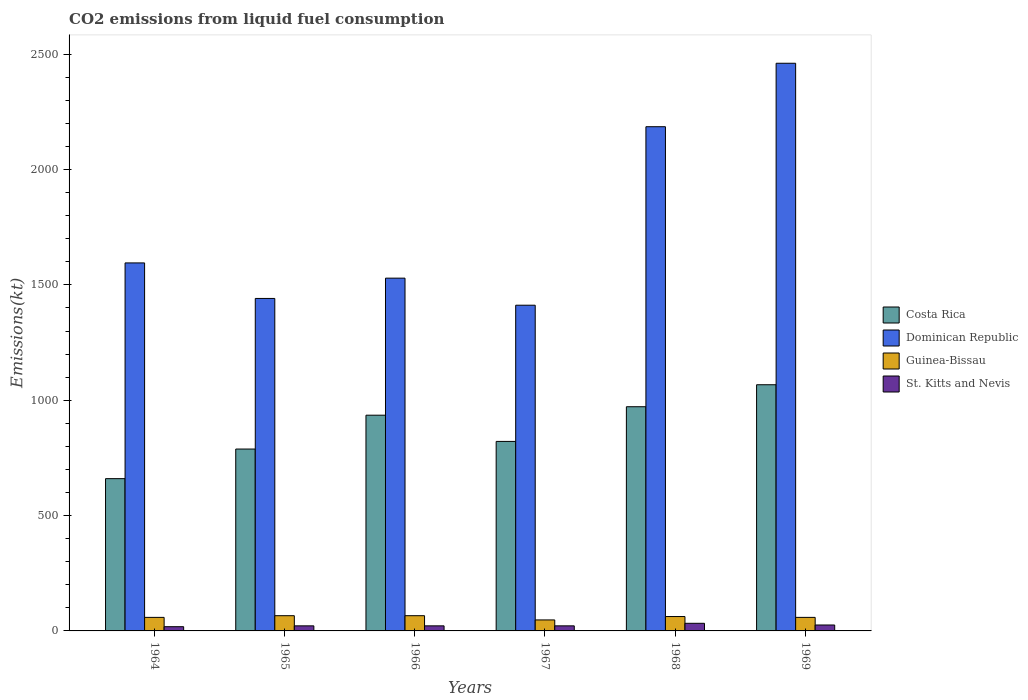How many groups of bars are there?
Provide a succinct answer. 6. Are the number of bars on each tick of the X-axis equal?
Keep it short and to the point. Yes. How many bars are there on the 4th tick from the right?
Offer a very short reply. 4. What is the label of the 6th group of bars from the left?
Your response must be concise. 1969. In how many cases, is the number of bars for a given year not equal to the number of legend labels?
Offer a terse response. 0. What is the amount of CO2 emitted in Guinea-Bissau in 1967?
Offer a terse response. 47.67. Across all years, what is the maximum amount of CO2 emitted in Guinea-Bissau?
Keep it short and to the point. 66.01. Across all years, what is the minimum amount of CO2 emitted in Costa Rica?
Ensure brevity in your answer.  660.06. In which year was the amount of CO2 emitted in St. Kitts and Nevis maximum?
Offer a very short reply. 1968. In which year was the amount of CO2 emitted in Costa Rica minimum?
Your answer should be compact. 1964. What is the total amount of CO2 emitted in Costa Rica in the graph?
Your response must be concise. 5243.81. What is the difference between the amount of CO2 emitted in Guinea-Bissau in 1965 and that in 1969?
Keep it short and to the point. 7.33. What is the difference between the amount of CO2 emitted in Costa Rica in 1968 and the amount of CO2 emitted in St. Kitts and Nevis in 1967?
Your response must be concise. 949.75. What is the average amount of CO2 emitted in Costa Rica per year?
Offer a terse response. 873.97. In the year 1964, what is the difference between the amount of CO2 emitted in Costa Rica and amount of CO2 emitted in Guinea-Bissau?
Your answer should be very brief. 601.39. In how many years, is the amount of CO2 emitted in Dominican Republic greater than 1900 kt?
Your answer should be compact. 2. What is the ratio of the amount of CO2 emitted in Guinea-Bissau in 1965 to that in 1967?
Offer a terse response. 1.38. Is the amount of CO2 emitted in Guinea-Bissau in 1967 less than that in 1969?
Give a very brief answer. Yes. What is the difference between the highest and the second highest amount of CO2 emitted in Costa Rica?
Keep it short and to the point. 95.34. What is the difference between the highest and the lowest amount of CO2 emitted in Costa Rica?
Ensure brevity in your answer.  407.04. In how many years, is the amount of CO2 emitted in St. Kitts and Nevis greater than the average amount of CO2 emitted in St. Kitts and Nevis taken over all years?
Give a very brief answer. 2. What does the 1st bar from the right in 1967 represents?
Provide a succinct answer. St. Kitts and Nevis. What is the title of the graph?
Keep it short and to the point. CO2 emissions from liquid fuel consumption. Does "Montenegro" appear as one of the legend labels in the graph?
Offer a very short reply. No. What is the label or title of the Y-axis?
Your response must be concise. Emissions(kt). What is the Emissions(kt) in Costa Rica in 1964?
Ensure brevity in your answer.  660.06. What is the Emissions(kt) in Dominican Republic in 1964?
Make the answer very short. 1595.14. What is the Emissions(kt) in Guinea-Bissau in 1964?
Give a very brief answer. 58.67. What is the Emissions(kt) in St. Kitts and Nevis in 1964?
Give a very brief answer. 18.34. What is the Emissions(kt) in Costa Rica in 1965?
Keep it short and to the point. 788.4. What is the Emissions(kt) in Dominican Republic in 1965?
Your response must be concise. 1441.13. What is the Emissions(kt) in Guinea-Bissau in 1965?
Offer a terse response. 66.01. What is the Emissions(kt) in St. Kitts and Nevis in 1965?
Make the answer very short. 22. What is the Emissions(kt) of Costa Rica in 1966?
Provide a succinct answer. 935.09. What is the Emissions(kt) of Dominican Republic in 1966?
Your answer should be compact. 1529.14. What is the Emissions(kt) in Guinea-Bissau in 1966?
Provide a succinct answer. 66.01. What is the Emissions(kt) of St. Kitts and Nevis in 1966?
Your response must be concise. 22. What is the Emissions(kt) in Costa Rica in 1967?
Offer a terse response. 821.41. What is the Emissions(kt) of Dominican Republic in 1967?
Give a very brief answer. 1411.8. What is the Emissions(kt) of Guinea-Bissau in 1967?
Offer a terse response. 47.67. What is the Emissions(kt) of St. Kitts and Nevis in 1967?
Keep it short and to the point. 22. What is the Emissions(kt) of Costa Rica in 1968?
Make the answer very short. 971.75. What is the Emissions(kt) of Dominican Republic in 1968?
Provide a succinct answer. 2185.53. What is the Emissions(kt) of Guinea-Bissau in 1968?
Keep it short and to the point. 62.34. What is the Emissions(kt) of St. Kitts and Nevis in 1968?
Give a very brief answer. 33. What is the Emissions(kt) of Costa Rica in 1969?
Your answer should be very brief. 1067.1. What is the Emissions(kt) in Dominican Republic in 1969?
Keep it short and to the point. 2460.56. What is the Emissions(kt) of Guinea-Bissau in 1969?
Your answer should be compact. 58.67. What is the Emissions(kt) in St. Kitts and Nevis in 1969?
Ensure brevity in your answer.  25.67. Across all years, what is the maximum Emissions(kt) of Costa Rica?
Give a very brief answer. 1067.1. Across all years, what is the maximum Emissions(kt) in Dominican Republic?
Ensure brevity in your answer.  2460.56. Across all years, what is the maximum Emissions(kt) in Guinea-Bissau?
Make the answer very short. 66.01. Across all years, what is the maximum Emissions(kt) in St. Kitts and Nevis?
Make the answer very short. 33. Across all years, what is the minimum Emissions(kt) in Costa Rica?
Provide a short and direct response. 660.06. Across all years, what is the minimum Emissions(kt) in Dominican Republic?
Offer a very short reply. 1411.8. Across all years, what is the minimum Emissions(kt) in Guinea-Bissau?
Your answer should be very brief. 47.67. Across all years, what is the minimum Emissions(kt) in St. Kitts and Nevis?
Your answer should be compact. 18.34. What is the total Emissions(kt) of Costa Rica in the graph?
Offer a terse response. 5243.81. What is the total Emissions(kt) in Dominican Republic in the graph?
Provide a short and direct response. 1.06e+04. What is the total Emissions(kt) in Guinea-Bissau in the graph?
Make the answer very short. 359.37. What is the total Emissions(kt) in St. Kitts and Nevis in the graph?
Give a very brief answer. 143.01. What is the difference between the Emissions(kt) of Costa Rica in 1964 and that in 1965?
Give a very brief answer. -128.34. What is the difference between the Emissions(kt) in Dominican Republic in 1964 and that in 1965?
Provide a short and direct response. 154.01. What is the difference between the Emissions(kt) of Guinea-Bissau in 1964 and that in 1965?
Your answer should be compact. -7.33. What is the difference between the Emissions(kt) in St. Kitts and Nevis in 1964 and that in 1965?
Provide a succinct answer. -3.67. What is the difference between the Emissions(kt) in Costa Rica in 1964 and that in 1966?
Keep it short and to the point. -275.02. What is the difference between the Emissions(kt) in Dominican Republic in 1964 and that in 1966?
Keep it short and to the point. 66.01. What is the difference between the Emissions(kt) of Guinea-Bissau in 1964 and that in 1966?
Ensure brevity in your answer.  -7.33. What is the difference between the Emissions(kt) in St. Kitts and Nevis in 1964 and that in 1966?
Offer a very short reply. -3.67. What is the difference between the Emissions(kt) of Costa Rica in 1964 and that in 1967?
Offer a very short reply. -161.35. What is the difference between the Emissions(kt) of Dominican Republic in 1964 and that in 1967?
Your response must be concise. 183.35. What is the difference between the Emissions(kt) of Guinea-Bissau in 1964 and that in 1967?
Your answer should be compact. 11. What is the difference between the Emissions(kt) in St. Kitts and Nevis in 1964 and that in 1967?
Give a very brief answer. -3.67. What is the difference between the Emissions(kt) of Costa Rica in 1964 and that in 1968?
Give a very brief answer. -311.69. What is the difference between the Emissions(kt) in Dominican Republic in 1964 and that in 1968?
Offer a very short reply. -590.39. What is the difference between the Emissions(kt) in Guinea-Bissau in 1964 and that in 1968?
Provide a short and direct response. -3.67. What is the difference between the Emissions(kt) of St. Kitts and Nevis in 1964 and that in 1968?
Give a very brief answer. -14.67. What is the difference between the Emissions(kt) in Costa Rica in 1964 and that in 1969?
Provide a succinct answer. -407.04. What is the difference between the Emissions(kt) of Dominican Republic in 1964 and that in 1969?
Provide a succinct answer. -865.41. What is the difference between the Emissions(kt) of Guinea-Bissau in 1964 and that in 1969?
Provide a short and direct response. 0. What is the difference between the Emissions(kt) of St. Kitts and Nevis in 1964 and that in 1969?
Provide a short and direct response. -7.33. What is the difference between the Emissions(kt) in Costa Rica in 1965 and that in 1966?
Your answer should be compact. -146.68. What is the difference between the Emissions(kt) in Dominican Republic in 1965 and that in 1966?
Your answer should be very brief. -88.01. What is the difference between the Emissions(kt) of Guinea-Bissau in 1965 and that in 1966?
Give a very brief answer. 0. What is the difference between the Emissions(kt) in Costa Rica in 1965 and that in 1967?
Provide a short and direct response. -33. What is the difference between the Emissions(kt) of Dominican Republic in 1965 and that in 1967?
Your response must be concise. 29.34. What is the difference between the Emissions(kt) of Guinea-Bissau in 1965 and that in 1967?
Ensure brevity in your answer.  18.34. What is the difference between the Emissions(kt) of Costa Rica in 1965 and that in 1968?
Keep it short and to the point. -183.35. What is the difference between the Emissions(kt) in Dominican Republic in 1965 and that in 1968?
Keep it short and to the point. -744.4. What is the difference between the Emissions(kt) of Guinea-Bissau in 1965 and that in 1968?
Keep it short and to the point. 3.67. What is the difference between the Emissions(kt) in St. Kitts and Nevis in 1965 and that in 1968?
Offer a very short reply. -11. What is the difference between the Emissions(kt) of Costa Rica in 1965 and that in 1969?
Offer a very short reply. -278.69. What is the difference between the Emissions(kt) in Dominican Republic in 1965 and that in 1969?
Provide a short and direct response. -1019.43. What is the difference between the Emissions(kt) of Guinea-Bissau in 1965 and that in 1969?
Ensure brevity in your answer.  7.33. What is the difference between the Emissions(kt) of St. Kitts and Nevis in 1965 and that in 1969?
Ensure brevity in your answer.  -3.67. What is the difference between the Emissions(kt) of Costa Rica in 1966 and that in 1967?
Your answer should be very brief. 113.68. What is the difference between the Emissions(kt) of Dominican Republic in 1966 and that in 1967?
Offer a very short reply. 117.34. What is the difference between the Emissions(kt) in Guinea-Bissau in 1966 and that in 1967?
Your answer should be compact. 18.34. What is the difference between the Emissions(kt) of Costa Rica in 1966 and that in 1968?
Your response must be concise. -36.67. What is the difference between the Emissions(kt) in Dominican Republic in 1966 and that in 1968?
Make the answer very short. -656.39. What is the difference between the Emissions(kt) in Guinea-Bissau in 1966 and that in 1968?
Give a very brief answer. 3.67. What is the difference between the Emissions(kt) of St. Kitts and Nevis in 1966 and that in 1968?
Your answer should be compact. -11. What is the difference between the Emissions(kt) in Costa Rica in 1966 and that in 1969?
Give a very brief answer. -132.01. What is the difference between the Emissions(kt) in Dominican Republic in 1966 and that in 1969?
Your response must be concise. -931.42. What is the difference between the Emissions(kt) in Guinea-Bissau in 1966 and that in 1969?
Keep it short and to the point. 7.33. What is the difference between the Emissions(kt) of St. Kitts and Nevis in 1966 and that in 1969?
Your response must be concise. -3.67. What is the difference between the Emissions(kt) in Costa Rica in 1967 and that in 1968?
Make the answer very short. -150.35. What is the difference between the Emissions(kt) of Dominican Republic in 1967 and that in 1968?
Give a very brief answer. -773.74. What is the difference between the Emissions(kt) in Guinea-Bissau in 1967 and that in 1968?
Your answer should be very brief. -14.67. What is the difference between the Emissions(kt) in St. Kitts and Nevis in 1967 and that in 1968?
Give a very brief answer. -11. What is the difference between the Emissions(kt) in Costa Rica in 1967 and that in 1969?
Offer a very short reply. -245.69. What is the difference between the Emissions(kt) in Dominican Republic in 1967 and that in 1969?
Your response must be concise. -1048.76. What is the difference between the Emissions(kt) in Guinea-Bissau in 1967 and that in 1969?
Your response must be concise. -11. What is the difference between the Emissions(kt) in St. Kitts and Nevis in 1967 and that in 1969?
Your answer should be very brief. -3.67. What is the difference between the Emissions(kt) in Costa Rica in 1968 and that in 1969?
Offer a terse response. -95.34. What is the difference between the Emissions(kt) of Dominican Republic in 1968 and that in 1969?
Keep it short and to the point. -275.02. What is the difference between the Emissions(kt) of Guinea-Bissau in 1968 and that in 1969?
Give a very brief answer. 3.67. What is the difference between the Emissions(kt) of St. Kitts and Nevis in 1968 and that in 1969?
Your answer should be compact. 7.33. What is the difference between the Emissions(kt) of Costa Rica in 1964 and the Emissions(kt) of Dominican Republic in 1965?
Offer a very short reply. -781.07. What is the difference between the Emissions(kt) in Costa Rica in 1964 and the Emissions(kt) in Guinea-Bissau in 1965?
Provide a succinct answer. 594.05. What is the difference between the Emissions(kt) in Costa Rica in 1964 and the Emissions(kt) in St. Kitts and Nevis in 1965?
Offer a terse response. 638.06. What is the difference between the Emissions(kt) of Dominican Republic in 1964 and the Emissions(kt) of Guinea-Bissau in 1965?
Ensure brevity in your answer.  1529.14. What is the difference between the Emissions(kt) in Dominican Republic in 1964 and the Emissions(kt) in St. Kitts and Nevis in 1965?
Your answer should be compact. 1573.14. What is the difference between the Emissions(kt) in Guinea-Bissau in 1964 and the Emissions(kt) in St. Kitts and Nevis in 1965?
Offer a terse response. 36.67. What is the difference between the Emissions(kt) of Costa Rica in 1964 and the Emissions(kt) of Dominican Republic in 1966?
Make the answer very short. -869.08. What is the difference between the Emissions(kt) of Costa Rica in 1964 and the Emissions(kt) of Guinea-Bissau in 1966?
Provide a succinct answer. 594.05. What is the difference between the Emissions(kt) in Costa Rica in 1964 and the Emissions(kt) in St. Kitts and Nevis in 1966?
Your response must be concise. 638.06. What is the difference between the Emissions(kt) in Dominican Republic in 1964 and the Emissions(kt) in Guinea-Bissau in 1966?
Give a very brief answer. 1529.14. What is the difference between the Emissions(kt) of Dominican Republic in 1964 and the Emissions(kt) of St. Kitts and Nevis in 1966?
Make the answer very short. 1573.14. What is the difference between the Emissions(kt) of Guinea-Bissau in 1964 and the Emissions(kt) of St. Kitts and Nevis in 1966?
Provide a short and direct response. 36.67. What is the difference between the Emissions(kt) in Costa Rica in 1964 and the Emissions(kt) in Dominican Republic in 1967?
Your answer should be compact. -751.74. What is the difference between the Emissions(kt) in Costa Rica in 1964 and the Emissions(kt) in Guinea-Bissau in 1967?
Provide a short and direct response. 612.39. What is the difference between the Emissions(kt) in Costa Rica in 1964 and the Emissions(kt) in St. Kitts and Nevis in 1967?
Your response must be concise. 638.06. What is the difference between the Emissions(kt) of Dominican Republic in 1964 and the Emissions(kt) of Guinea-Bissau in 1967?
Provide a short and direct response. 1547.47. What is the difference between the Emissions(kt) in Dominican Republic in 1964 and the Emissions(kt) in St. Kitts and Nevis in 1967?
Provide a short and direct response. 1573.14. What is the difference between the Emissions(kt) in Guinea-Bissau in 1964 and the Emissions(kt) in St. Kitts and Nevis in 1967?
Offer a terse response. 36.67. What is the difference between the Emissions(kt) of Costa Rica in 1964 and the Emissions(kt) of Dominican Republic in 1968?
Your response must be concise. -1525.47. What is the difference between the Emissions(kt) of Costa Rica in 1964 and the Emissions(kt) of Guinea-Bissau in 1968?
Your answer should be very brief. 597.72. What is the difference between the Emissions(kt) in Costa Rica in 1964 and the Emissions(kt) in St. Kitts and Nevis in 1968?
Offer a very short reply. 627.06. What is the difference between the Emissions(kt) of Dominican Republic in 1964 and the Emissions(kt) of Guinea-Bissau in 1968?
Offer a terse response. 1532.81. What is the difference between the Emissions(kt) of Dominican Republic in 1964 and the Emissions(kt) of St. Kitts and Nevis in 1968?
Your response must be concise. 1562.14. What is the difference between the Emissions(kt) in Guinea-Bissau in 1964 and the Emissions(kt) in St. Kitts and Nevis in 1968?
Your answer should be compact. 25.67. What is the difference between the Emissions(kt) of Costa Rica in 1964 and the Emissions(kt) of Dominican Republic in 1969?
Offer a terse response. -1800.5. What is the difference between the Emissions(kt) of Costa Rica in 1964 and the Emissions(kt) of Guinea-Bissau in 1969?
Provide a succinct answer. 601.39. What is the difference between the Emissions(kt) of Costa Rica in 1964 and the Emissions(kt) of St. Kitts and Nevis in 1969?
Keep it short and to the point. 634.39. What is the difference between the Emissions(kt) of Dominican Republic in 1964 and the Emissions(kt) of Guinea-Bissau in 1969?
Offer a very short reply. 1536.47. What is the difference between the Emissions(kt) in Dominican Republic in 1964 and the Emissions(kt) in St. Kitts and Nevis in 1969?
Offer a terse response. 1569.48. What is the difference between the Emissions(kt) in Guinea-Bissau in 1964 and the Emissions(kt) in St. Kitts and Nevis in 1969?
Offer a terse response. 33. What is the difference between the Emissions(kt) in Costa Rica in 1965 and the Emissions(kt) in Dominican Republic in 1966?
Keep it short and to the point. -740.73. What is the difference between the Emissions(kt) of Costa Rica in 1965 and the Emissions(kt) of Guinea-Bissau in 1966?
Provide a short and direct response. 722.4. What is the difference between the Emissions(kt) in Costa Rica in 1965 and the Emissions(kt) in St. Kitts and Nevis in 1966?
Your answer should be very brief. 766.4. What is the difference between the Emissions(kt) in Dominican Republic in 1965 and the Emissions(kt) in Guinea-Bissau in 1966?
Offer a terse response. 1375.12. What is the difference between the Emissions(kt) in Dominican Republic in 1965 and the Emissions(kt) in St. Kitts and Nevis in 1966?
Your answer should be compact. 1419.13. What is the difference between the Emissions(kt) in Guinea-Bissau in 1965 and the Emissions(kt) in St. Kitts and Nevis in 1966?
Offer a very short reply. 44. What is the difference between the Emissions(kt) of Costa Rica in 1965 and the Emissions(kt) of Dominican Republic in 1967?
Give a very brief answer. -623.39. What is the difference between the Emissions(kt) of Costa Rica in 1965 and the Emissions(kt) of Guinea-Bissau in 1967?
Ensure brevity in your answer.  740.73. What is the difference between the Emissions(kt) of Costa Rica in 1965 and the Emissions(kt) of St. Kitts and Nevis in 1967?
Make the answer very short. 766.4. What is the difference between the Emissions(kt) in Dominican Republic in 1965 and the Emissions(kt) in Guinea-Bissau in 1967?
Give a very brief answer. 1393.46. What is the difference between the Emissions(kt) of Dominican Republic in 1965 and the Emissions(kt) of St. Kitts and Nevis in 1967?
Make the answer very short. 1419.13. What is the difference between the Emissions(kt) of Guinea-Bissau in 1965 and the Emissions(kt) of St. Kitts and Nevis in 1967?
Provide a succinct answer. 44. What is the difference between the Emissions(kt) in Costa Rica in 1965 and the Emissions(kt) in Dominican Republic in 1968?
Make the answer very short. -1397.13. What is the difference between the Emissions(kt) in Costa Rica in 1965 and the Emissions(kt) in Guinea-Bissau in 1968?
Keep it short and to the point. 726.07. What is the difference between the Emissions(kt) of Costa Rica in 1965 and the Emissions(kt) of St. Kitts and Nevis in 1968?
Keep it short and to the point. 755.4. What is the difference between the Emissions(kt) of Dominican Republic in 1965 and the Emissions(kt) of Guinea-Bissau in 1968?
Provide a short and direct response. 1378.79. What is the difference between the Emissions(kt) in Dominican Republic in 1965 and the Emissions(kt) in St. Kitts and Nevis in 1968?
Provide a succinct answer. 1408.13. What is the difference between the Emissions(kt) of Guinea-Bissau in 1965 and the Emissions(kt) of St. Kitts and Nevis in 1968?
Provide a short and direct response. 33. What is the difference between the Emissions(kt) in Costa Rica in 1965 and the Emissions(kt) in Dominican Republic in 1969?
Offer a terse response. -1672.15. What is the difference between the Emissions(kt) of Costa Rica in 1965 and the Emissions(kt) of Guinea-Bissau in 1969?
Give a very brief answer. 729.73. What is the difference between the Emissions(kt) of Costa Rica in 1965 and the Emissions(kt) of St. Kitts and Nevis in 1969?
Offer a very short reply. 762.74. What is the difference between the Emissions(kt) in Dominican Republic in 1965 and the Emissions(kt) in Guinea-Bissau in 1969?
Your answer should be very brief. 1382.46. What is the difference between the Emissions(kt) in Dominican Republic in 1965 and the Emissions(kt) in St. Kitts and Nevis in 1969?
Keep it short and to the point. 1415.46. What is the difference between the Emissions(kt) in Guinea-Bissau in 1965 and the Emissions(kt) in St. Kitts and Nevis in 1969?
Ensure brevity in your answer.  40.34. What is the difference between the Emissions(kt) in Costa Rica in 1966 and the Emissions(kt) in Dominican Republic in 1967?
Your response must be concise. -476.71. What is the difference between the Emissions(kt) of Costa Rica in 1966 and the Emissions(kt) of Guinea-Bissau in 1967?
Keep it short and to the point. 887.41. What is the difference between the Emissions(kt) of Costa Rica in 1966 and the Emissions(kt) of St. Kitts and Nevis in 1967?
Ensure brevity in your answer.  913.08. What is the difference between the Emissions(kt) of Dominican Republic in 1966 and the Emissions(kt) of Guinea-Bissau in 1967?
Your answer should be compact. 1481.47. What is the difference between the Emissions(kt) in Dominican Republic in 1966 and the Emissions(kt) in St. Kitts and Nevis in 1967?
Make the answer very short. 1507.14. What is the difference between the Emissions(kt) of Guinea-Bissau in 1966 and the Emissions(kt) of St. Kitts and Nevis in 1967?
Provide a short and direct response. 44. What is the difference between the Emissions(kt) of Costa Rica in 1966 and the Emissions(kt) of Dominican Republic in 1968?
Offer a terse response. -1250.45. What is the difference between the Emissions(kt) of Costa Rica in 1966 and the Emissions(kt) of Guinea-Bissau in 1968?
Your answer should be very brief. 872.75. What is the difference between the Emissions(kt) in Costa Rica in 1966 and the Emissions(kt) in St. Kitts and Nevis in 1968?
Provide a succinct answer. 902.08. What is the difference between the Emissions(kt) in Dominican Republic in 1966 and the Emissions(kt) in Guinea-Bissau in 1968?
Your answer should be compact. 1466.8. What is the difference between the Emissions(kt) of Dominican Republic in 1966 and the Emissions(kt) of St. Kitts and Nevis in 1968?
Your answer should be compact. 1496.14. What is the difference between the Emissions(kt) of Guinea-Bissau in 1966 and the Emissions(kt) of St. Kitts and Nevis in 1968?
Offer a terse response. 33. What is the difference between the Emissions(kt) in Costa Rica in 1966 and the Emissions(kt) in Dominican Republic in 1969?
Your answer should be compact. -1525.47. What is the difference between the Emissions(kt) of Costa Rica in 1966 and the Emissions(kt) of Guinea-Bissau in 1969?
Provide a succinct answer. 876.41. What is the difference between the Emissions(kt) in Costa Rica in 1966 and the Emissions(kt) in St. Kitts and Nevis in 1969?
Provide a short and direct response. 909.42. What is the difference between the Emissions(kt) of Dominican Republic in 1966 and the Emissions(kt) of Guinea-Bissau in 1969?
Provide a succinct answer. 1470.47. What is the difference between the Emissions(kt) in Dominican Republic in 1966 and the Emissions(kt) in St. Kitts and Nevis in 1969?
Ensure brevity in your answer.  1503.47. What is the difference between the Emissions(kt) of Guinea-Bissau in 1966 and the Emissions(kt) of St. Kitts and Nevis in 1969?
Offer a very short reply. 40.34. What is the difference between the Emissions(kt) of Costa Rica in 1967 and the Emissions(kt) of Dominican Republic in 1968?
Your answer should be very brief. -1364.12. What is the difference between the Emissions(kt) of Costa Rica in 1967 and the Emissions(kt) of Guinea-Bissau in 1968?
Keep it short and to the point. 759.07. What is the difference between the Emissions(kt) in Costa Rica in 1967 and the Emissions(kt) in St. Kitts and Nevis in 1968?
Your answer should be compact. 788.4. What is the difference between the Emissions(kt) of Dominican Republic in 1967 and the Emissions(kt) of Guinea-Bissau in 1968?
Give a very brief answer. 1349.46. What is the difference between the Emissions(kt) of Dominican Republic in 1967 and the Emissions(kt) of St. Kitts and Nevis in 1968?
Make the answer very short. 1378.79. What is the difference between the Emissions(kt) in Guinea-Bissau in 1967 and the Emissions(kt) in St. Kitts and Nevis in 1968?
Your response must be concise. 14.67. What is the difference between the Emissions(kt) in Costa Rica in 1967 and the Emissions(kt) in Dominican Republic in 1969?
Your answer should be compact. -1639.15. What is the difference between the Emissions(kt) of Costa Rica in 1967 and the Emissions(kt) of Guinea-Bissau in 1969?
Offer a terse response. 762.74. What is the difference between the Emissions(kt) in Costa Rica in 1967 and the Emissions(kt) in St. Kitts and Nevis in 1969?
Offer a very short reply. 795.74. What is the difference between the Emissions(kt) of Dominican Republic in 1967 and the Emissions(kt) of Guinea-Bissau in 1969?
Your response must be concise. 1353.12. What is the difference between the Emissions(kt) in Dominican Republic in 1967 and the Emissions(kt) in St. Kitts and Nevis in 1969?
Keep it short and to the point. 1386.13. What is the difference between the Emissions(kt) of Guinea-Bissau in 1967 and the Emissions(kt) of St. Kitts and Nevis in 1969?
Provide a short and direct response. 22. What is the difference between the Emissions(kt) of Costa Rica in 1968 and the Emissions(kt) of Dominican Republic in 1969?
Provide a short and direct response. -1488.8. What is the difference between the Emissions(kt) in Costa Rica in 1968 and the Emissions(kt) in Guinea-Bissau in 1969?
Offer a very short reply. 913.08. What is the difference between the Emissions(kt) of Costa Rica in 1968 and the Emissions(kt) of St. Kitts and Nevis in 1969?
Offer a very short reply. 946.09. What is the difference between the Emissions(kt) in Dominican Republic in 1968 and the Emissions(kt) in Guinea-Bissau in 1969?
Your response must be concise. 2126.86. What is the difference between the Emissions(kt) in Dominican Republic in 1968 and the Emissions(kt) in St. Kitts and Nevis in 1969?
Provide a succinct answer. 2159.86. What is the difference between the Emissions(kt) of Guinea-Bissau in 1968 and the Emissions(kt) of St. Kitts and Nevis in 1969?
Provide a succinct answer. 36.67. What is the average Emissions(kt) in Costa Rica per year?
Your answer should be very brief. 873.97. What is the average Emissions(kt) of Dominican Republic per year?
Your response must be concise. 1770.55. What is the average Emissions(kt) in Guinea-Bissau per year?
Offer a very short reply. 59.89. What is the average Emissions(kt) in St. Kitts and Nevis per year?
Ensure brevity in your answer.  23.84. In the year 1964, what is the difference between the Emissions(kt) of Costa Rica and Emissions(kt) of Dominican Republic?
Your response must be concise. -935.09. In the year 1964, what is the difference between the Emissions(kt) in Costa Rica and Emissions(kt) in Guinea-Bissau?
Offer a terse response. 601.39. In the year 1964, what is the difference between the Emissions(kt) in Costa Rica and Emissions(kt) in St. Kitts and Nevis?
Offer a very short reply. 641.73. In the year 1964, what is the difference between the Emissions(kt) of Dominican Republic and Emissions(kt) of Guinea-Bissau?
Give a very brief answer. 1536.47. In the year 1964, what is the difference between the Emissions(kt) in Dominican Republic and Emissions(kt) in St. Kitts and Nevis?
Ensure brevity in your answer.  1576.81. In the year 1964, what is the difference between the Emissions(kt) of Guinea-Bissau and Emissions(kt) of St. Kitts and Nevis?
Offer a very short reply. 40.34. In the year 1965, what is the difference between the Emissions(kt) of Costa Rica and Emissions(kt) of Dominican Republic?
Ensure brevity in your answer.  -652.73. In the year 1965, what is the difference between the Emissions(kt) of Costa Rica and Emissions(kt) of Guinea-Bissau?
Ensure brevity in your answer.  722.4. In the year 1965, what is the difference between the Emissions(kt) of Costa Rica and Emissions(kt) of St. Kitts and Nevis?
Your answer should be compact. 766.4. In the year 1965, what is the difference between the Emissions(kt) in Dominican Republic and Emissions(kt) in Guinea-Bissau?
Ensure brevity in your answer.  1375.12. In the year 1965, what is the difference between the Emissions(kt) of Dominican Republic and Emissions(kt) of St. Kitts and Nevis?
Give a very brief answer. 1419.13. In the year 1965, what is the difference between the Emissions(kt) in Guinea-Bissau and Emissions(kt) in St. Kitts and Nevis?
Offer a terse response. 44. In the year 1966, what is the difference between the Emissions(kt) in Costa Rica and Emissions(kt) in Dominican Republic?
Ensure brevity in your answer.  -594.05. In the year 1966, what is the difference between the Emissions(kt) in Costa Rica and Emissions(kt) in Guinea-Bissau?
Make the answer very short. 869.08. In the year 1966, what is the difference between the Emissions(kt) in Costa Rica and Emissions(kt) in St. Kitts and Nevis?
Provide a succinct answer. 913.08. In the year 1966, what is the difference between the Emissions(kt) in Dominican Republic and Emissions(kt) in Guinea-Bissau?
Give a very brief answer. 1463.13. In the year 1966, what is the difference between the Emissions(kt) in Dominican Republic and Emissions(kt) in St. Kitts and Nevis?
Give a very brief answer. 1507.14. In the year 1966, what is the difference between the Emissions(kt) of Guinea-Bissau and Emissions(kt) of St. Kitts and Nevis?
Provide a succinct answer. 44. In the year 1967, what is the difference between the Emissions(kt) in Costa Rica and Emissions(kt) in Dominican Republic?
Provide a short and direct response. -590.39. In the year 1967, what is the difference between the Emissions(kt) in Costa Rica and Emissions(kt) in Guinea-Bissau?
Your response must be concise. 773.74. In the year 1967, what is the difference between the Emissions(kt) of Costa Rica and Emissions(kt) of St. Kitts and Nevis?
Offer a very short reply. 799.41. In the year 1967, what is the difference between the Emissions(kt) in Dominican Republic and Emissions(kt) in Guinea-Bissau?
Provide a succinct answer. 1364.12. In the year 1967, what is the difference between the Emissions(kt) of Dominican Republic and Emissions(kt) of St. Kitts and Nevis?
Your answer should be compact. 1389.79. In the year 1967, what is the difference between the Emissions(kt) of Guinea-Bissau and Emissions(kt) of St. Kitts and Nevis?
Offer a terse response. 25.67. In the year 1968, what is the difference between the Emissions(kt) of Costa Rica and Emissions(kt) of Dominican Republic?
Offer a very short reply. -1213.78. In the year 1968, what is the difference between the Emissions(kt) in Costa Rica and Emissions(kt) in Guinea-Bissau?
Make the answer very short. 909.42. In the year 1968, what is the difference between the Emissions(kt) in Costa Rica and Emissions(kt) in St. Kitts and Nevis?
Give a very brief answer. 938.75. In the year 1968, what is the difference between the Emissions(kt) of Dominican Republic and Emissions(kt) of Guinea-Bissau?
Offer a terse response. 2123.19. In the year 1968, what is the difference between the Emissions(kt) in Dominican Republic and Emissions(kt) in St. Kitts and Nevis?
Your response must be concise. 2152.53. In the year 1968, what is the difference between the Emissions(kt) in Guinea-Bissau and Emissions(kt) in St. Kitts and Nevis?
Give a very brief answer. 29.34. In the year 1969, what is the difference between the Emissions(kt) in Costa Rica and Emissions(kt) in Dominican Republic?
Ensure brevity in your answer.  -1393.46. In the year 1969, what is the difference between the Emissions(kt) of Costa Rica and Emissions(kt) of Guinea-Bissau?
Provide a succinct answer. 1008.42. In the year 1969, what is the difference between the Emissions(kt) of Costa Rica and Emissions(kt) of St. Kitts and Nevis?
Provide a short and direct response. 1041.43. In the year 1969, what is the difference between the Emissions(kt) in Dominican Republic and Emissions(kt) in Guinea-Bissau?
Give a very brief answer. 2401.89. In the year 1969, what is the difference between the Emissions(kt) of Dominican Republic and Emissions(kt) of St. Kitts and Nevis?
Make the answer very short. 2434.89. In the year 1969, what is the difference between the Emissions(kt) in Guinea-Bissau and Emissions(kt) in St. Kitts and Nevis?
Provide a succinct answer. 33. What is the ratio of the Emissions(kt) in Costa Rica in 1964 to that in 1965?
Your response must be concise. 0.84. What is the ratio of the Emissions(kt) in Dominican Republic in 1964 to that in 1965?
Ensure brevity in your answer.  1.11. What is the ratio of the Emissions(kt) of Guinea-Bissau in 1964 to that in 1965?
Your answer should be very brief. 0.89. What is the ratio of the Emissions(kt) in St. Kitts and Nevis in 1964 to that in 1965?
Keep it short and to the point. 0.83. What is the ratio of the Emissions(kt) of Costa Rica in 1964 to that in 1966?
Ensure brevity in your answer.  0.71. What is the ratio of the Emissions(kt) in Dominican Republic in 1964 to that in 1966?
Offer a terse response. 1.04. What is the ratio of the Emissions(kt) of Costa Rica in 1964 to that in 1967?
Your answer should be very brief. 0.8. What is the ratio of the Emissions(kt) of Dominican Republic in 1964 to that in 1967?
Make the answer very short. 1.13. What is the ratio of the Emissions(kt) of Guinea-Bissau in 1964 to that in 1967?
Offer a terse response. 1.23. What is the ratio of the Emissions(kt) in Costa Rica in 1964 to that in 1968?
Make the answer very short. 0.68. What is the ratio of the Emissions(kt) in Dominican Republic in 1964 to that in 1968?
Give a very brief answer. 0.73. What is the ratio of the Emissions(kt) of St. Kitts and Nevis in 1964 to that in 1968?
Keep it short and to the point. 0.56. What is the ratio of the Emissions(kt) of Costa Rica in 1964 to that in 1969?
Your response must be concise. 0.62. What is the ratio of the Emissions(kt) in Dominican Republic in 1964 to that in 1969?
Your response must be concise. 0.65. What is the ratio of the Emissions(kt) in Costa Rica in 1965 to that in 1966?
Your response must be concise. 0.84. What is the ratio of the Emissions(kt) of Dominican Republic in 1965 to that in 1966?
Your response must be concise. 0.94. What is the ratio of the Emissions(kt) in Costa Rica in 1965 to that in 1967?
Make the answer very short. 0.96. What is the ratio of the Emissions(kt) in Dominican Republic in 1965 to that in 1967?
Your answer should be very brief. 1.02. What is the ratio of the Emissions(kt) of Guinea-Bissau in 1965 to that in 1967?
Offer a terse response. 1.38. What is the ratio of the Emissions(kt) of St. Kitts and Nevis in 1965 to that in 1967?
Your answer should be compact. 1. What is the ratio of the Emissions(kt) of Costa Rica in 1965 to that in 1968?
Offer a terse response. 0.81. What is the ratio of the Emissions(kt) in Dominican Republic in 1965 to that in 1968?
Keep it short and to the point. 0.66. What is the ratio of the Emissions(kt) in Guinea-Bissau in 1965 to that in 1968?
Keep it short and to the point. 1.06. What is the ratio of the Emissions(kt) of Costa Rica in 1965 to that in 1969?
Provide a succinct answer. 0.74. What is the ratio of the Emissions(kt) of Dominican Republic in 1965 to that in 1969?
Offer a terse response. 0.59. What is the ratio of the Emissions(kt) of Guinea-Bissau in 1965 to that in 1969?
Offer a terse response. 1.12. What is the ratio of the Emissions(kt) in Costa Rica in 1966 to that in 1967?
Offer a very short reply. 1.14. What is the ratio of the Emissions(kt) of Dominican Republic in 1966 to that in 1967?
Offer a very short reply. 1.08. What is the ratio of the Emissions(kt) of Guinea-Bissau in 1966 to that in 1967?
Ensure brevity in your answer.  1.38. What is the ratio of the Emissions(kt) in St. Kitts and Nevis in 1966 to that in 1967?
Provide a short and direct response. 1. What is the ratio of the Emissions(kt) in Costa Rica in 1966 to that in 1968?
Ensure brevity in your answer.  0.96. What is the ratio of the Emissions(kt) in Dominican Republic in 1966 to that in 1968?
Ensure brevity in your answer.  0.7. What is the ratio of the Emissions(kt) in Guinea-Bissau in 1966 to that in 1968?
Ensure brevity in your answer.  1.06. What is the ratio of the Emissions(kt) in St. Kitts and Nevis in 1966 to that in 1968?
Your answer should be very brief. 0.67. What is the ratio of the Emissions(kt) of Costa Rica in 1966 to that in 1969?
Offer a very short reply. 0.88. What is the ratio of the Emissions(kt) in Dominican Republic in 1966 to that in 1969?
Your response must be concise. 0.62. What is the ratio of the Emissions(kt) in Guinea-Bissau in 1966 to that in 1969?
Keep it short and to the point. 1.12. What is the ratio of the Emissions(kt) in Costa Rica in 1967 to that in 1968?
Offer a terse response. 0.85. What is the ratio of the Emissions(kt) of Dominican Republic in 1967 to that in 1968?
Keep it short and to the point. 0.65. What is the ratio of the Emissions(kt) of Guinea-Bissau in 1967 to that in 1968?
Your answer should be compact. 0.76. What is the ratio of the Emissions(kt) in Costa Rica in 1967 to that in 1969?
Give a very brief answer. 0.77. What is the ratio of the Emissions(kt) in Dominican Republic in 1967 to that in 1969?
Offer a very short reply. 0.57. What is the ratio of the Emissions(kt) of Guinea-Bissau in 1967 to that in 1969?
Give a very brief answer. 0.81. What is the ratio of the Emissions(kt) in Costa Rica in 1968 to that in 1969?
Ensure brevity in your answer.  0.91. What is the ratio of the Emissions(kt) in Dominican Republic in 1968 to that in 1969?
Offer a terse response. 0.89. What is the ratio of the Emissions(kt) in Guinea-Bissau in 1968 to that in 1969?
Offer a very short reply. 1.06. What is the ratio of the Emissions(kt) of St. Kitts and Nevis in 1968 to that in 1969?
Offer a very short reply. 1.29. What is the difference between the highest and the second highest Emissions(kt) in Costa Rica?
Ensure brevity in your answer.  95.34. What is the difference between the highest and the second highest Emissions(kt) in Dominican Republic?
Give a very brief answer. 275.02. What is the difference between the highest and the second highest Emissions(kt) in Guinea-Bissau?
Provide a short and direct response. 0. What is the difference between the highest and the second highest Emissions(kt) of St. Kitts and Nevis?
Offer a very short reply. 7.33. What is the difference between the highest and the lowest Emissions(kt) of Costa Rica?
Make the answer very short. 407.04. What is the difference between the highest and the lowest Emissions(kt) of Dominican Republic?
Offer a very short reply. 1048.76. What is the difference between the highest and the lowest Emissions(kt) of Guinea-Bissau?
Provide a short and direct response. 18.34. What is the difference between the highest and the lowest Emissions(kt) in St. Kitts and Nevis?
Your answer should be very brief. 14.67. 